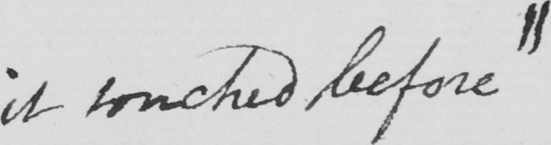Transcribe the text shown in this historical manuscript line. it touched before|| 